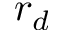<formula> <loc_0><loc_0><loc_500><loc_500>r _ { d }</formula> 